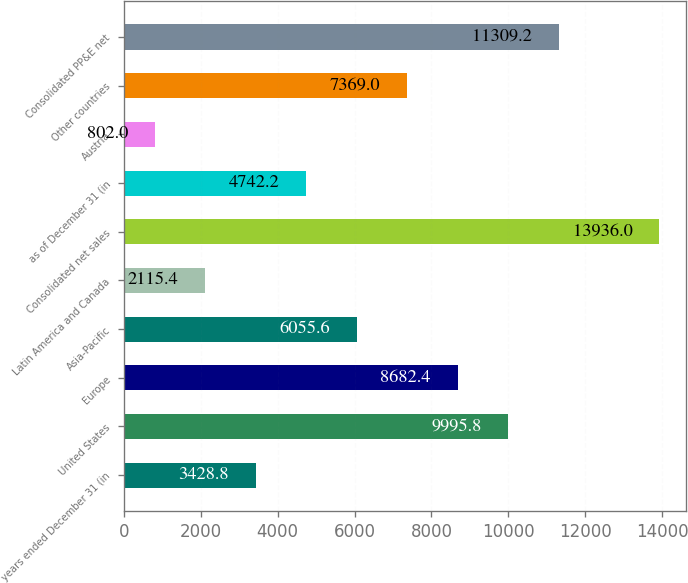Convert chart. <chart><loc_0><loc_0><loc_500><loc_500><bar_chart><fcel>years ended December 31 (in<fcel>United States<fcel>Europe<fcel>Asia-Pacific<fcel>Latin America and Canada<fcel>Consolidated net sales<fcel>as of December 31 (in<fcel>Austria<fcel>Other countries<fcel>Consolidated PP&E net<nl><fcel>3428.8<fcel>9995.8<fcel>8682.4<fcel>6055.6<fcel>2115.4<fcel>13936<fcel>4742.2<fcel>802<fcel>7369<fcel>11309.2<nl></chart> 